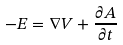Convert formula to latex. <formula><loc_0><loc_0><loc_500><loc_500>- E = \nabla V + \frac { \partial A } { \partial t }</formula> 